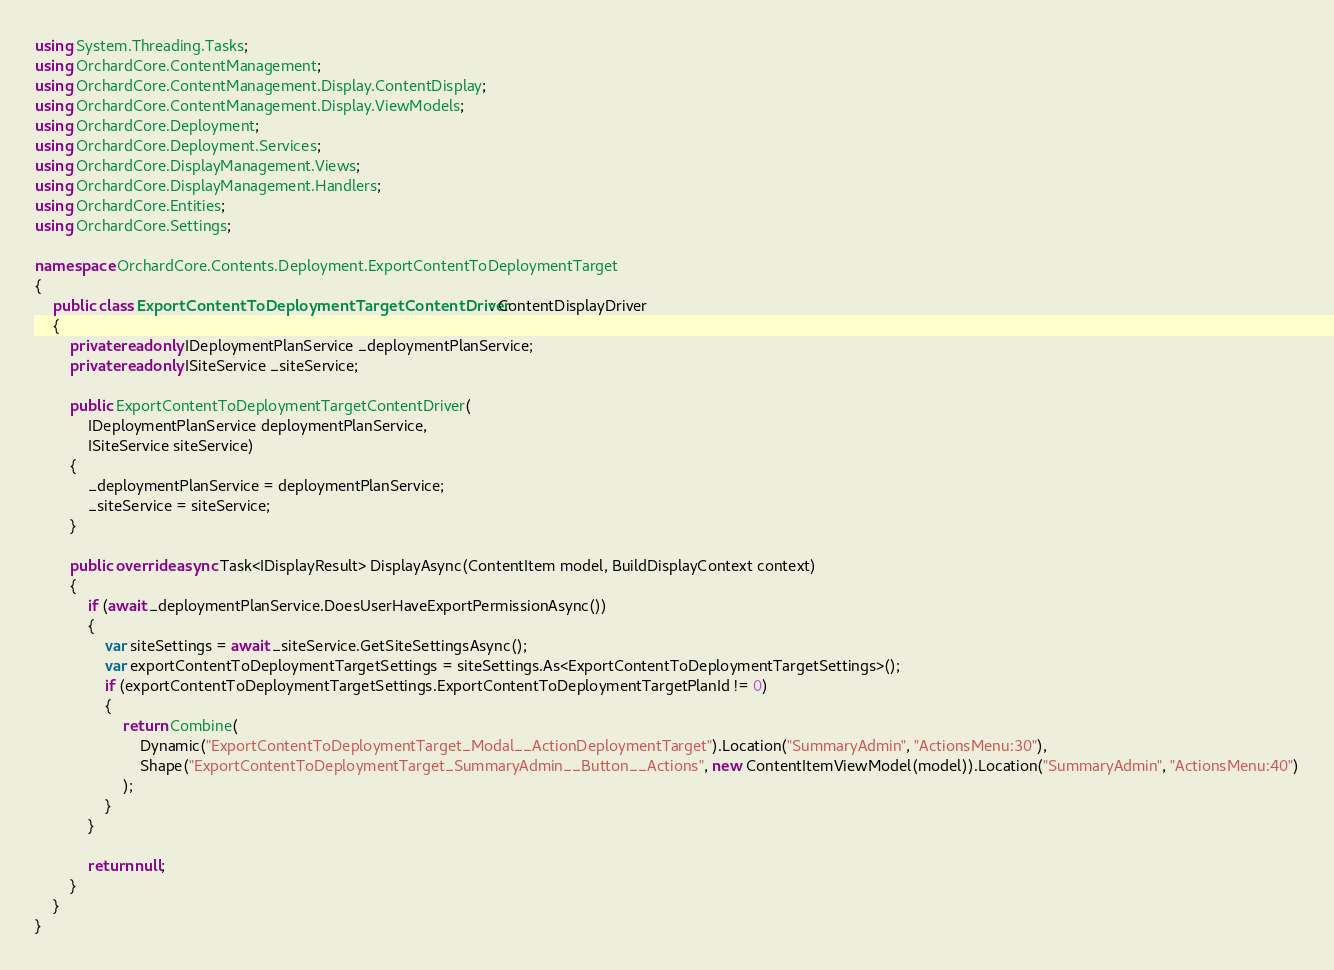Convert code to text. <code><loc_0><loc_0><loc_500><loc_500><_C#_>using System.Threading.Tasks;
using OrchardCore.ContentManagement;
using OrchardCore.ContentManagement.Display.ContentDisplay;
using OrchardCore.ContentManagement.Display.ViewModels;
using OrchardCore.Deployment;
using OrchardCore.Deployment.Services;
using OrchardCore.DisplayManagement.Views;
using OrchardCore.DisplayManagement.Handlers;
using OrchardCore.Entities;
using OrchardCore.Settings;

namespace OrchardCore.Contents.Deployment.ExportContentToDeploymentTarget
{
    public class ExportContentToDeploymentTargetContentDriver : ContentDisplayDriver
    {
        private readonly IDeploymentPlanService _deploymentPlanService;
        private readonly ISiteService _siteService;

        public ExportContentToDeploymentTargetContentDriver(
            IDeploymentPlanService deploymentPlanService,
            ISiteService siteService)
        {
            _deploymentPlanService = deploymentPlanService;
            _siteService = siteService;
        }

        public override async Task<IDisplayResult> DisplayAsync(ContentItem model, BuildDisplayContext context)
        {
            if (await _deploymentPlanService.DoesUserHaveExportPermissionAsync())
            {
                var siteSettings = await _siteService.GetSiteSettingsAsync();
                var exportContentToDeploymentTargetSettings = siteSettings.As<ExportContentToDeploymentTargetSettings>();
                if (exportContentToDeploymentTargetSettings.ExportContentToDeploymentTargetPlanId != 0)
                {
                    return Combine(
                        Dynamic("ExportContentToDeploymentTarget_Modal__ActionDeploymentTarget").Location("SummaryAdmin", "ActionsMenu:30"),
                        Shape("ExportContentToDeploymentTarget_SummaryAdmin__Button__Actions", new ContentItemViewModel(model)).Location("SummaryAdmin", "ActionsMenu:40")
                    );
                }
            }

            return null;
        }
    }
}
</code> 